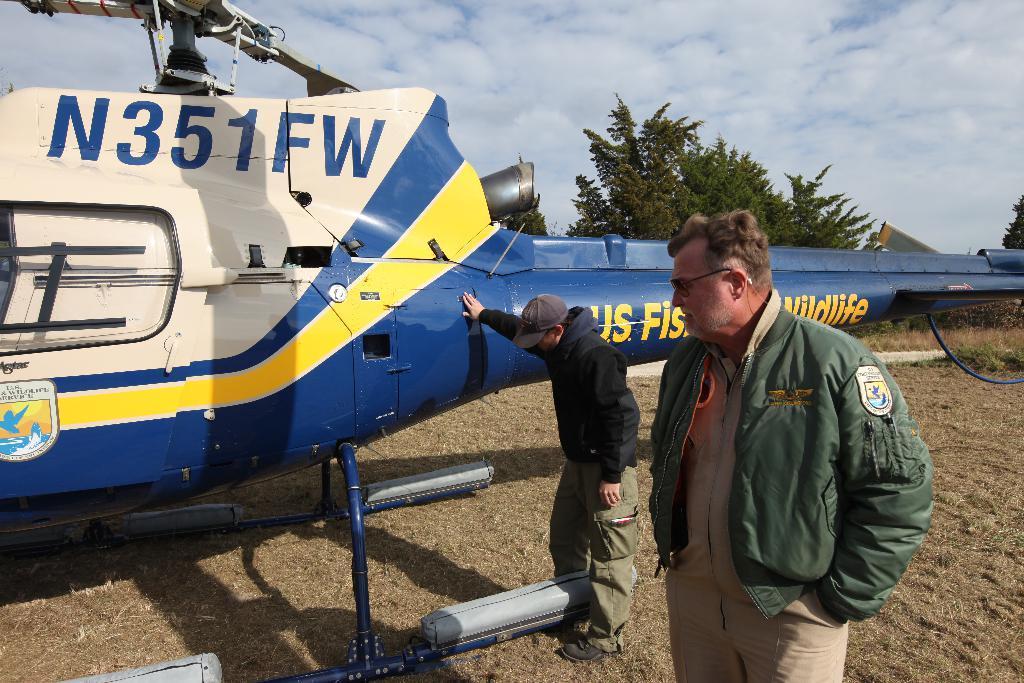Can you describe this image briefly? In this picture there is a white and blue helicopter parked on the ground. In front there are two men wearing a green jacket and brown pant looking to the helicopter. Behind there are some trees. 